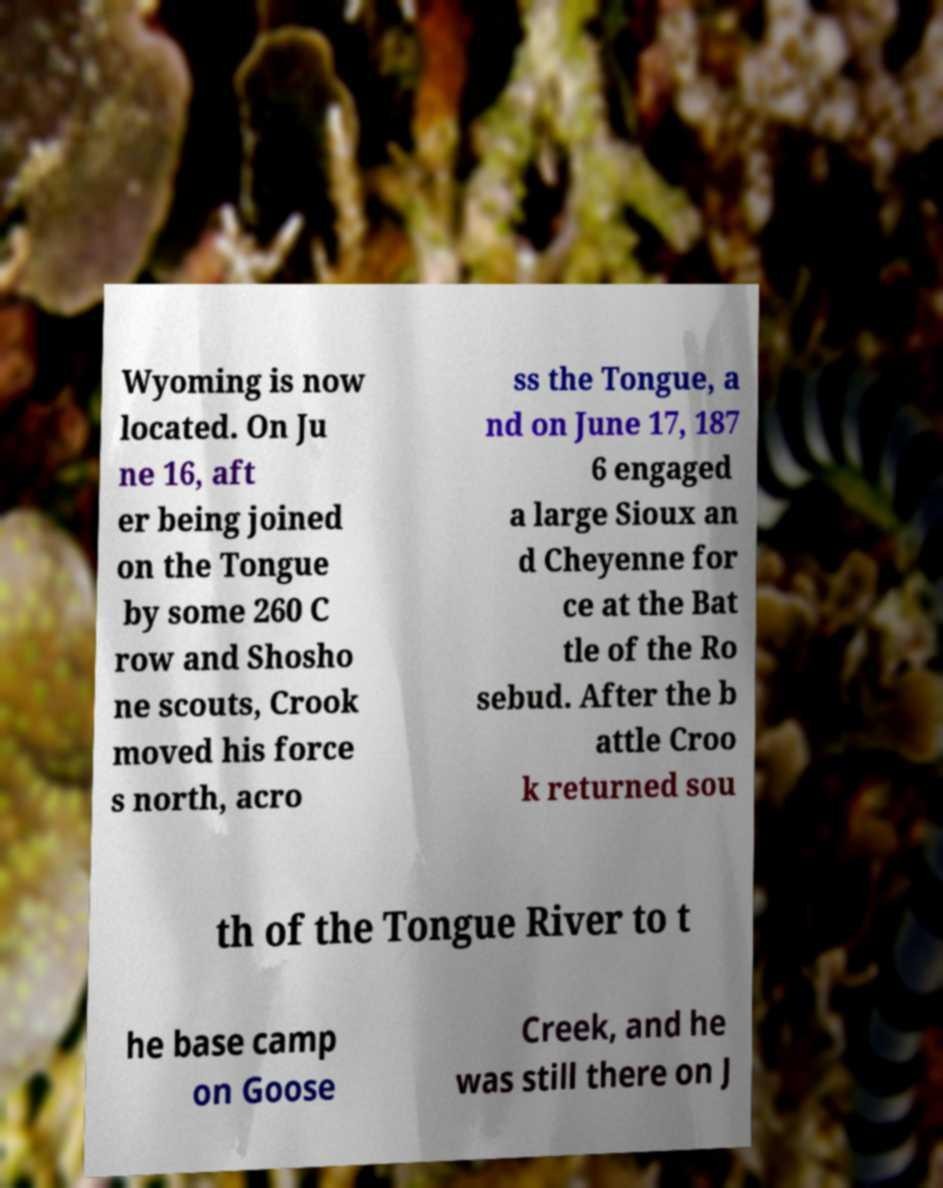Could you assist in decoding the text presented in this image and type it out clearly? Wyoming is now located. On Ju ne 16, aft er being joined on the Tongue by some 260 C row and Shosho ne scouts, Crook moved his force s north, acro ss the Tongue, a nd on June 17, 187 6 engaged a large Sioux an d Cheyenne for ce at the Bat tle of the Ro sebud. After the b attle Croo k returned sou th of the Tongue River to t he base camp on Goose Creek, and he was still there on J 